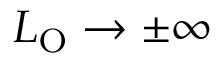Convert formula to latex. <formula><loc_0><loc_0><loc_500><loc_500>L _ { O } \rightarrow \pm \infty</formula> 